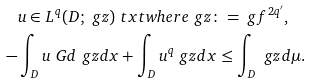<formula> <loc_0><loc_0><loc_500><loc_500>& u \in L ^ { q } ( D ; \ g z ) \ t x t { w h e r e } \ g z \colon = \ g f ^ { 2 q ^ { \prime } } , \\ - & \int _ { D } u \ G d \ g z d x + \int _ { D } u ^ { q } \ g z d x \leq \int _ { D } \ g z d \mu .</formula> 